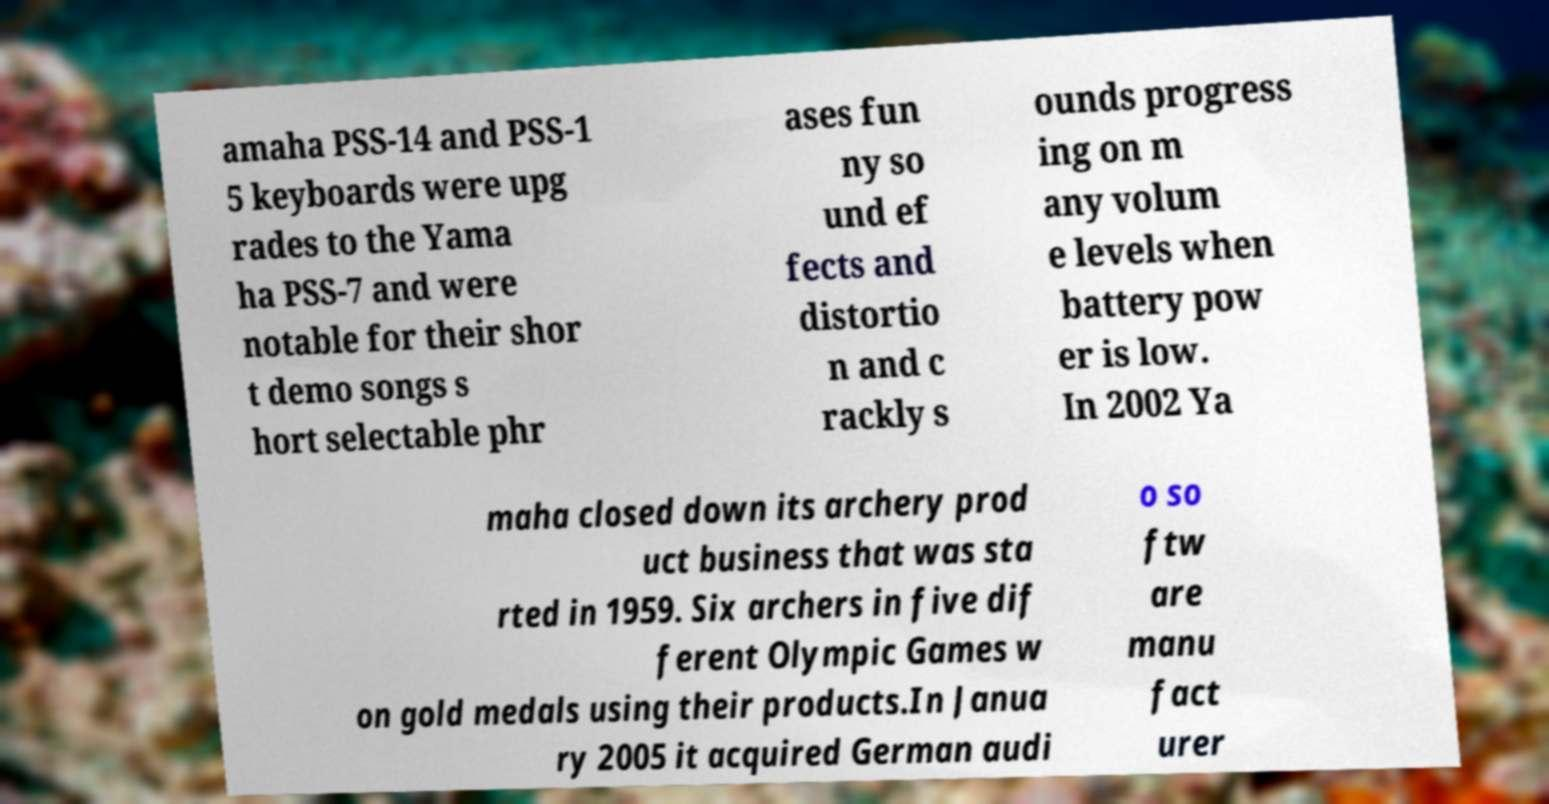Could you assist in decoding the text presented in this image and type it out clearly? amaha PSS-14 and PSS-1 5 keyboards were upg rades to the Yama ha PSS-7 and were notable for their shor t demo songs s hort selectable phr ases fun ny so und ef fects and distortio n and c rackly s ounds progress ing on m any volum e levels when battery pow er is low. In 2002 Ya maha closed down its archery prod uct business that was sta rted in 1959. Six archers in five dif ferent Olympic Games w on gold medals using their products.In Janua ry 2005 it acquired German audi o so ftw are manu fact urer 